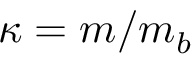<formula> <loc_0><loc_0><loc_500><loc_500>\kappa = m / m _ { b }</formula> 